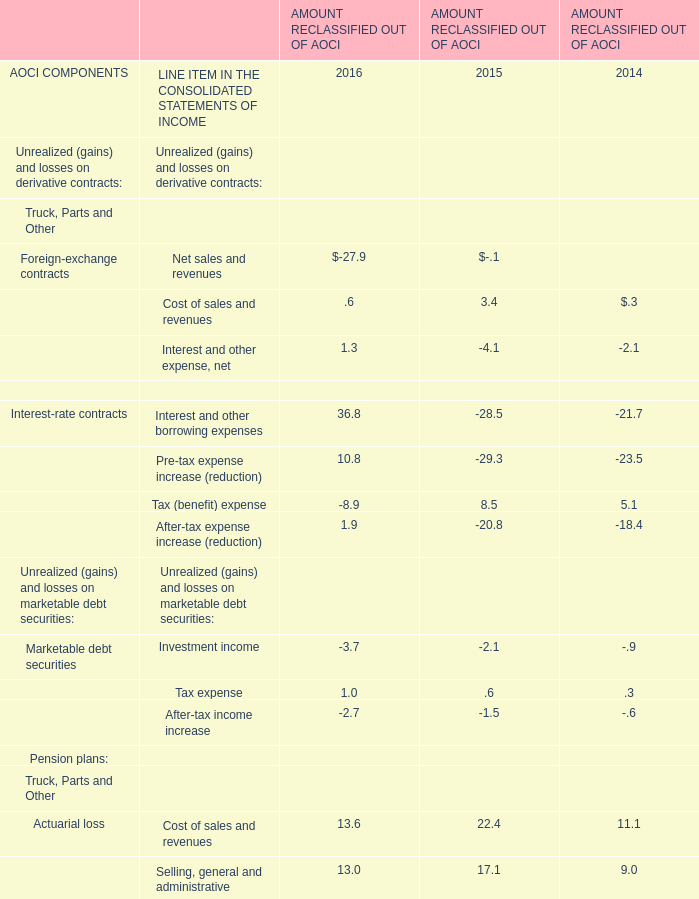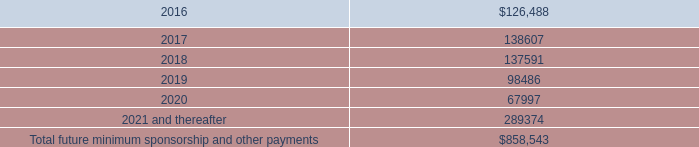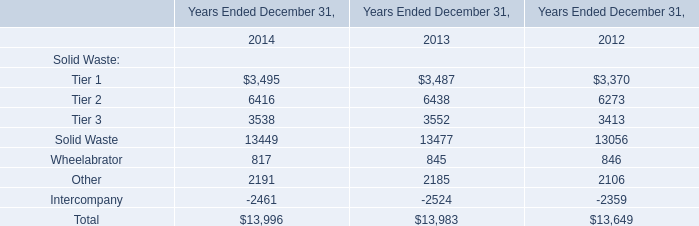what was the percent change in rent expense included in the the selling , general and administrative expense from 2014 to 2015 
Computations: ((83.0 - 59.0) / 59.0)
Answer: 0.40678. 